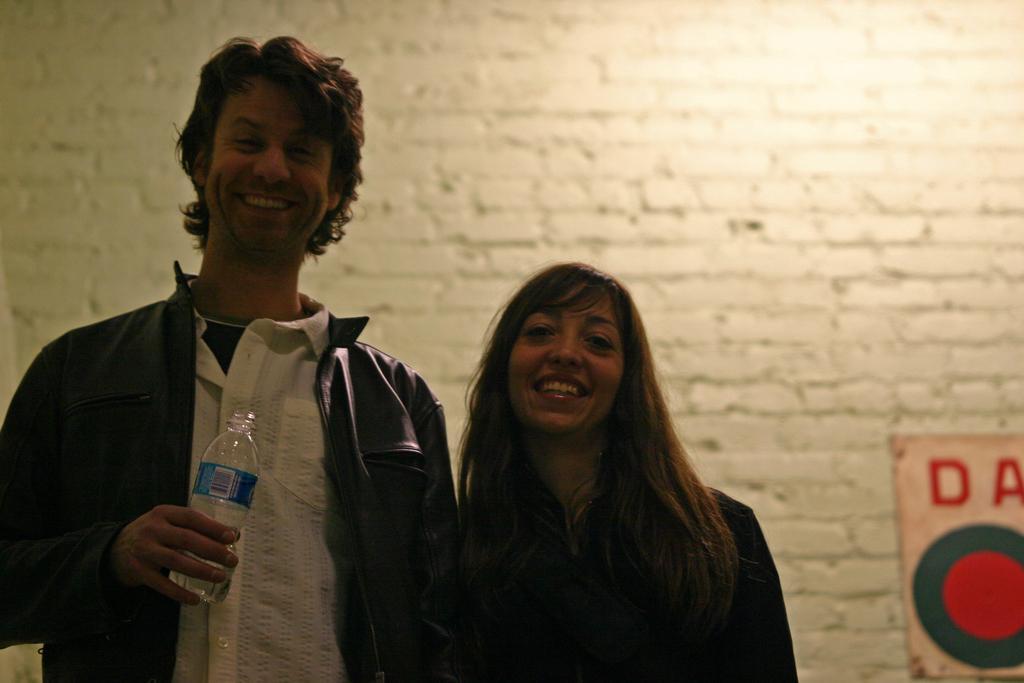Describe this image in one or two sentences. There is a man and woman standing. Man is holding a water bottle and he is wearing leather jacket. Woman is standing and smiling. At background there is a white colored wall and some sticker is attached to the wall. 